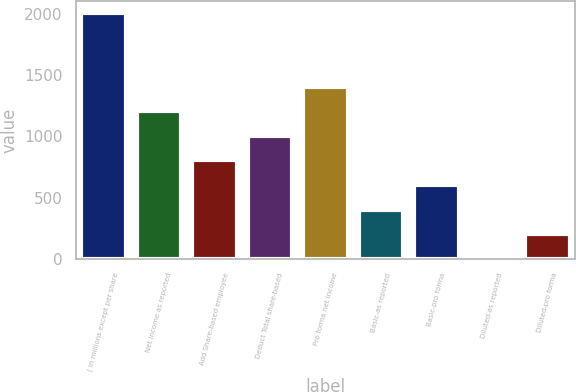Convert chart to OTSL. <chart><loc_0><loc_0><loc_500><loc_500><bar_chart><fcel>( in millions except per share<fcel>Net income as reported<fcel>Add Share-based employee<fcel>Deduct Total share-based<fcel>Pro forma net income<fcel>Basic-as reported<fcel>Basic-pro forma<fcel>Diluted-as reported<fcel>Diluted-pro forma<nl><fcel>2007<fcel>1204.91<fcel>803.87<fcel>1004.39<fcel>1405.44<fcel>402.81<fcel>603.34<fcel>1.75<fcel>202.28<nl></chart> 